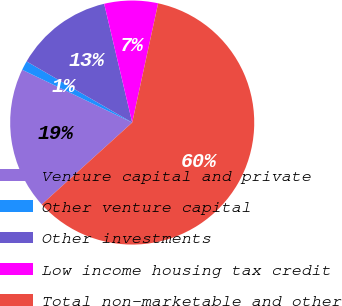<chart> <loc_0><loc_0><loc_500><loc_500><pie_chart><fcel>Venture capital and private<fcel>Other venture capital<fcel>Other investments<fcel>Low income housing tax credit<fcel>Total non-marketable and other<nl><fcel>18.83%<fcel>1.23%<fcel>12.96%<fcel>7.1%<fcel>59.88%<nl></chart> 